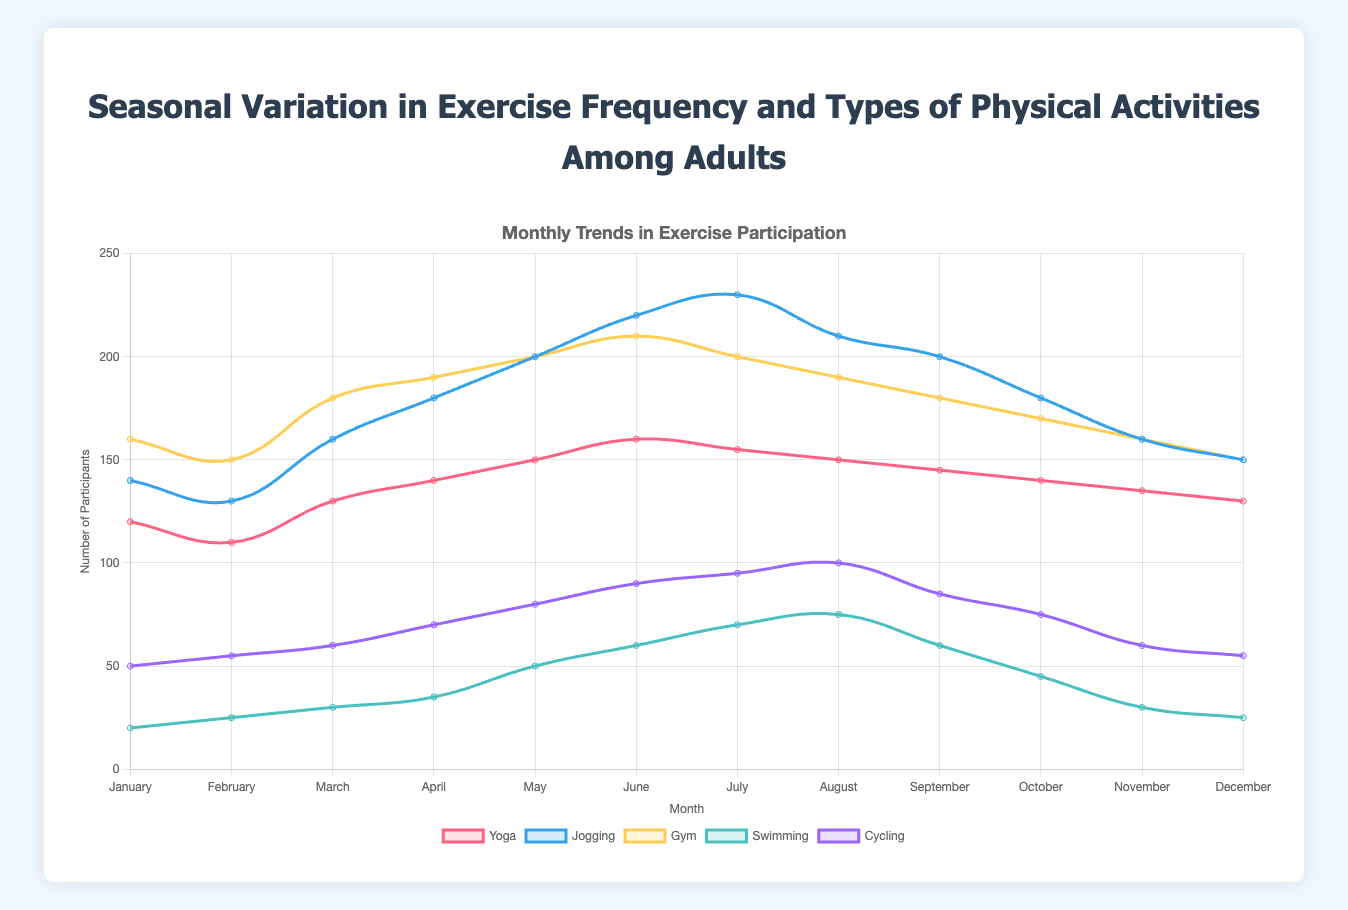Which month saw the highest participation in jogging? The highest point on the jogging line in the graph corresponds to July.
Answer: July How does the participation in gym activities in January compare to that in December? The line for gym activities shows both January and December have participation numbers; in January, it's 160, and in December, it's 150. Thus, January has higher participation.
Answer: January What's the difference between the highest and lowest participation in swimming? The highest participation in swimming is in August (75) and the lowest is in January (20). The difference is 75 - 20 = 55.
Answer: 55 During which months does cycling participation see a noticeable increase? From the graph, noticeable increases appear from April to May, and from May to June.
Answer: April, May, June Which activity shows a consistent upward trend from January to June? By observing the slopes in the graph, yoga shows a consistent upward trend every month from January to June.
Answer: Yoga In which month is the gap between yoga and cycling participation the smallest? To determine this, observe the graph where both lines are closest together; in August, both lines are around 150 and 100, the gap is 50, which is among the smallest.
Answer: August What is the average participation in yoga over the year? Summing up yoga participation for each month: 120 + 110 + 130 + 140 + 150 + 160 + 155 + 150 + 145 + 140 + 135 + 130 = 1665. Dividing by 12 months, the average is 1665 / 12 = 138.75.
Answer: 138.75 Which activity had the smallest fluctuation in participation throughout the year? Comparing the range (difference between max and min values) for each activity, gym has the smallest range from 150 to 210 (a difference of 60).
Answer: Gym How does swimming participation in May compare to June? The swimming participation in May (50) is lower than in June (60).
Answer: Lower When does jogging participation peak and by how much does it exceed the previous month's participation? Jogging peaks in July with 230 participants, and in June, it had 220 participants, so it exceeds the previous month by 230 - 220 = 10.
Answer: July, 10 